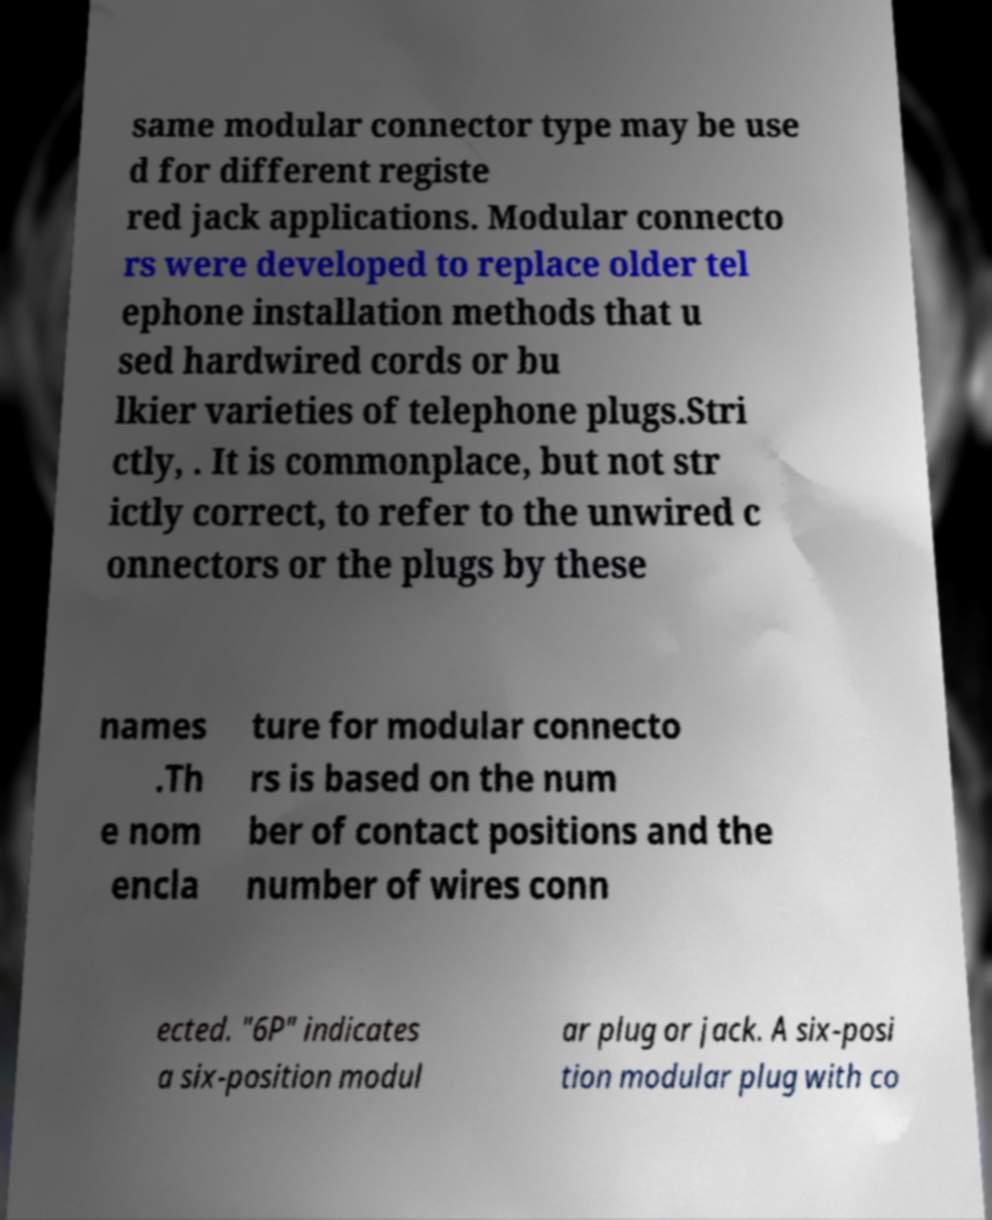Please read and relay the text visible in this image. What does it say? same modular connector type may be use d for different registe red jack applications. Modular connecto rs were developed to replace older tel ephone installation methods that u sed hardwired cords or bu lkier varieties of telephone plugs.Stri ctly, . It is commonplace, but not str ictly correct, to refer to the unwired c onnectors or the plugs by these names .Th e nom encla ture for modular connecto rs is based on the num ber of contact positions and the number of wires conn ected. "6P" indicates a six-position modul ar plug or jack. A six-posi tion modular plug with co 